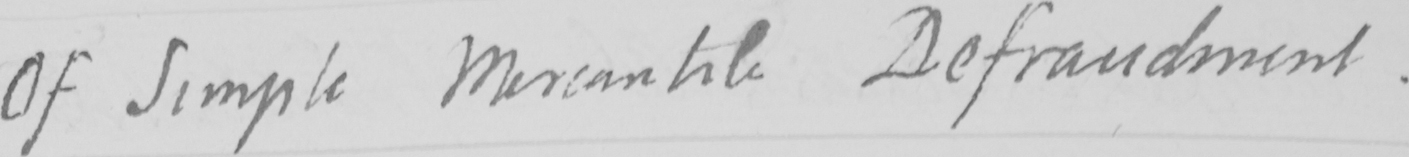What is written in this line of handwriting? Of Simple Mercantile Defraudment . 